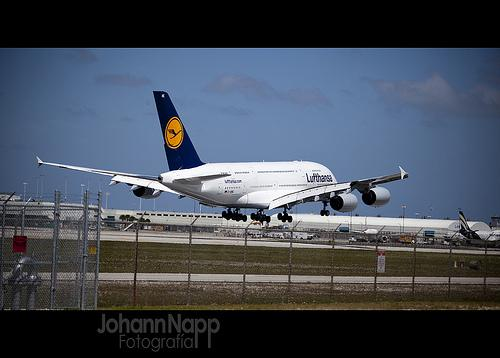Note down the primary subject and its main activity in the image. Lufthansa aircraft in the process of taking off from the airport, with its wheels still not retracted. Choose the most important object in the image and present its function. A Lufthansa airplane is performing its takeoff maneuver from the airport runway. Briefly describe the scene captured in the image. A Lufthansa airplane is in mid-takeoff, with its wheels down, at an airport surrounded by a high wire fence. Portray the main action of the image, including the central element involved. The image shows a Lufthansa aircraft taking off from an airport runway with its wheels still down. Identify the pivotal object in the image and what it is doing. A Lufthansa plane is the focal point, as it takes off from the runway with its landing gear not yet retracted. State the main object in the image and describe the action being performed. The Lufthansa airplane is the main object, currently taking off from the airport with its wheels down. What is the central focus of the image and what is happening? The focal point is a Lufthansa airplane taking off from a runway, with its wheels down and a blue sky above. Express the key components and actions in the picture. Lufthansa aircraft taking off, wheels not yet retracted, fenced airport, sky with scattered grayish clouds. Paint a mental picture of the image focusing on the main elements. Lufthansa airplane departing, wheels still down, fenced-off airport, blue sky with scattered clouds. Mention the primary object in the image and its most significant action. An aircraft belonging to Lufthansa is taking off from the airport runway with its wheels remaining down. 